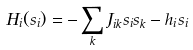<formula> <loc_0><loc_0><loc_500><loc_500>H _ { i } ( s _ { i } ) = - \sum _ { k } J _ { i k } s _ { i } s _ { k } - h _ { i } s _ { i }</formula> 